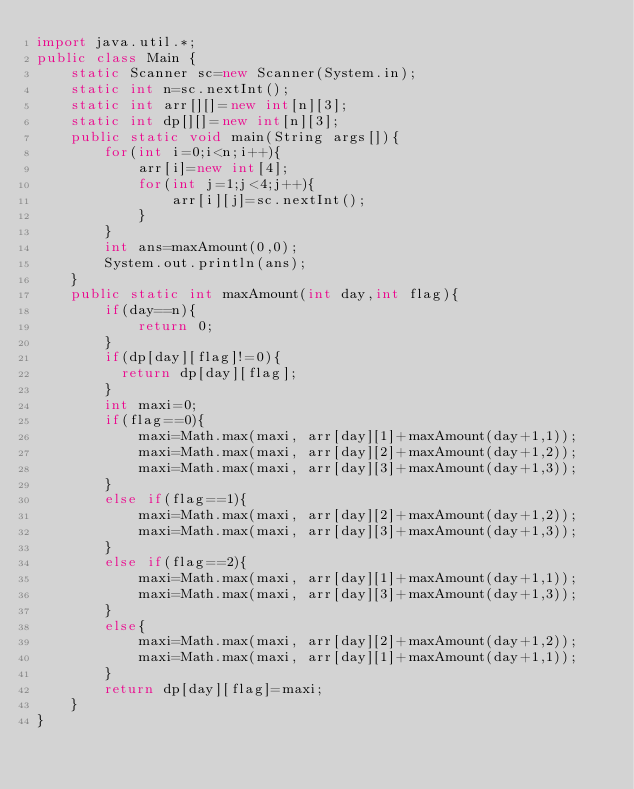Convert code to text. <code><loc_0><loc_0><loc_500><loc_500><_Java_>import java.util.*;
public class Main {
	static Scanner sc=new Scanner(System.in);
	static int n=sc.nextInt();
	static int arr[][]=new int[n][3];
  	static int dp[][]=new int[n][3];
	public static void main(String args[]){
		for(int i=0;i<n;i++){
			arr[i]=new int[4];
			for(int j=1;j<4;j++){
				arr[i][j]=sc.nextInt();
			}
		}
		int ans=maxAmount(0,0);
		System.out.println(ans);
	}
	public static int maxAmount(int day,int flag){
		if(day==n){
			return 0;
		}
      	if(dp[day][flag]!=0){
          return dp[day][flag];
        }
		int maxi=0;
		if(flag==0){
			maxi=Math.max(maxi, arr[day][1]+maxAmount(day+1,1));
			maxi=Math.max(maxi, arr[day][2]+maxAmount(day+1,2));
			maxi=Math.max(maxi, arr[day][3]+maxAmount(day+1,3));
		}
		else if(flag==1){
			maxi=Math.max(maxi, arr[day][2]+maxAmount(day+1,2));
			maxi=Math.max(maxi, arr[day][3]+maxAmount(day+1,3));
		}
		else if(flag==2){
			maxi=Math.max(maxi, arr[day][1]+maxAmount(day+1,1));
			maxi=Math.max(maxi, arr[day][3]+maxAmount(day+1,3));
		}
		else{
			maxi=Math.max(maxi, arr[day][2]+maxAmount(day+1,2));
			maxi=Math.max(maxi, arr[day][1]+maxAmount(day+1,1));
		}
		return dp[day][flag]=maxi;
	}
}
</code> 